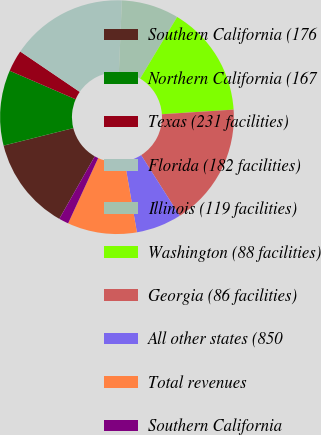Convert chart. <chart><loc_0><loc_0><loc_500><loc_500><pie_chart><fcel>Southern California (176<fcel>Northern California (167<fcel>Texas (231 facilities)<fcel>Florida (182 facilities)<fcel>Illinois (119 facilities)<fcel>Washington (88 facilities)<fcel>Georgia (86 facilities)<fcel>All other states (850<fcel>Total revenues<fcel>Southern California<nl><fcel>12.88%<fcel>10.41%<fcel>2.99%<fcel>16.18%<fcel>7.94%<fcel>15.36%<fcel>17.01%<fcel>6.29%<fcel>9.59%<fcel>1.35%<nl></chart> 